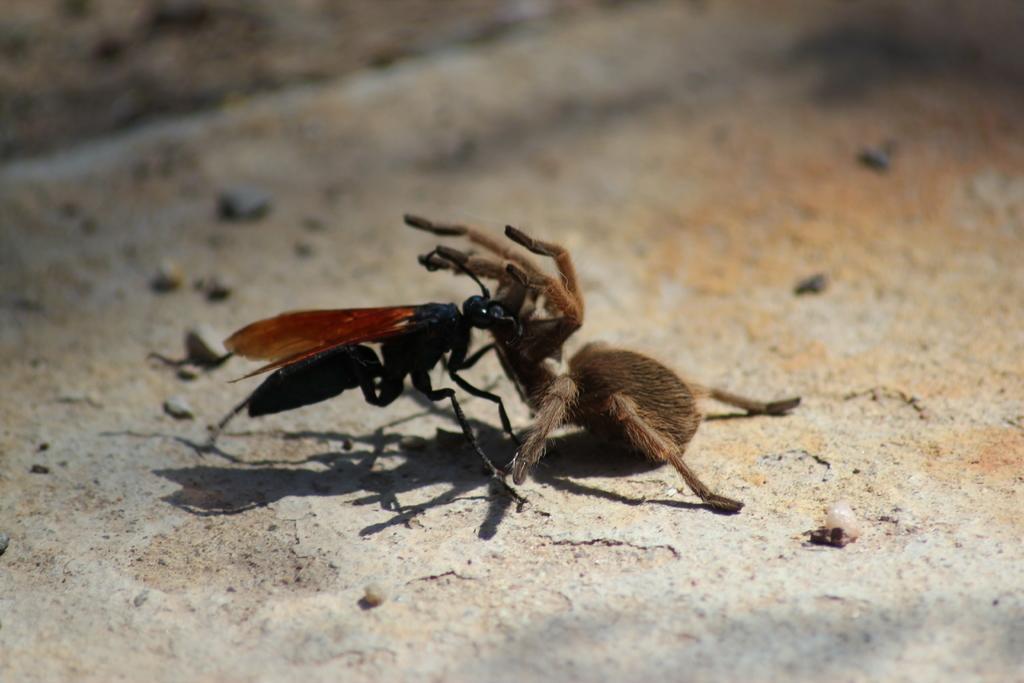In one or two sentences, can you explain what this image depicts? In this image we can see an ant and a spider. In the background of the image there is the ground. 